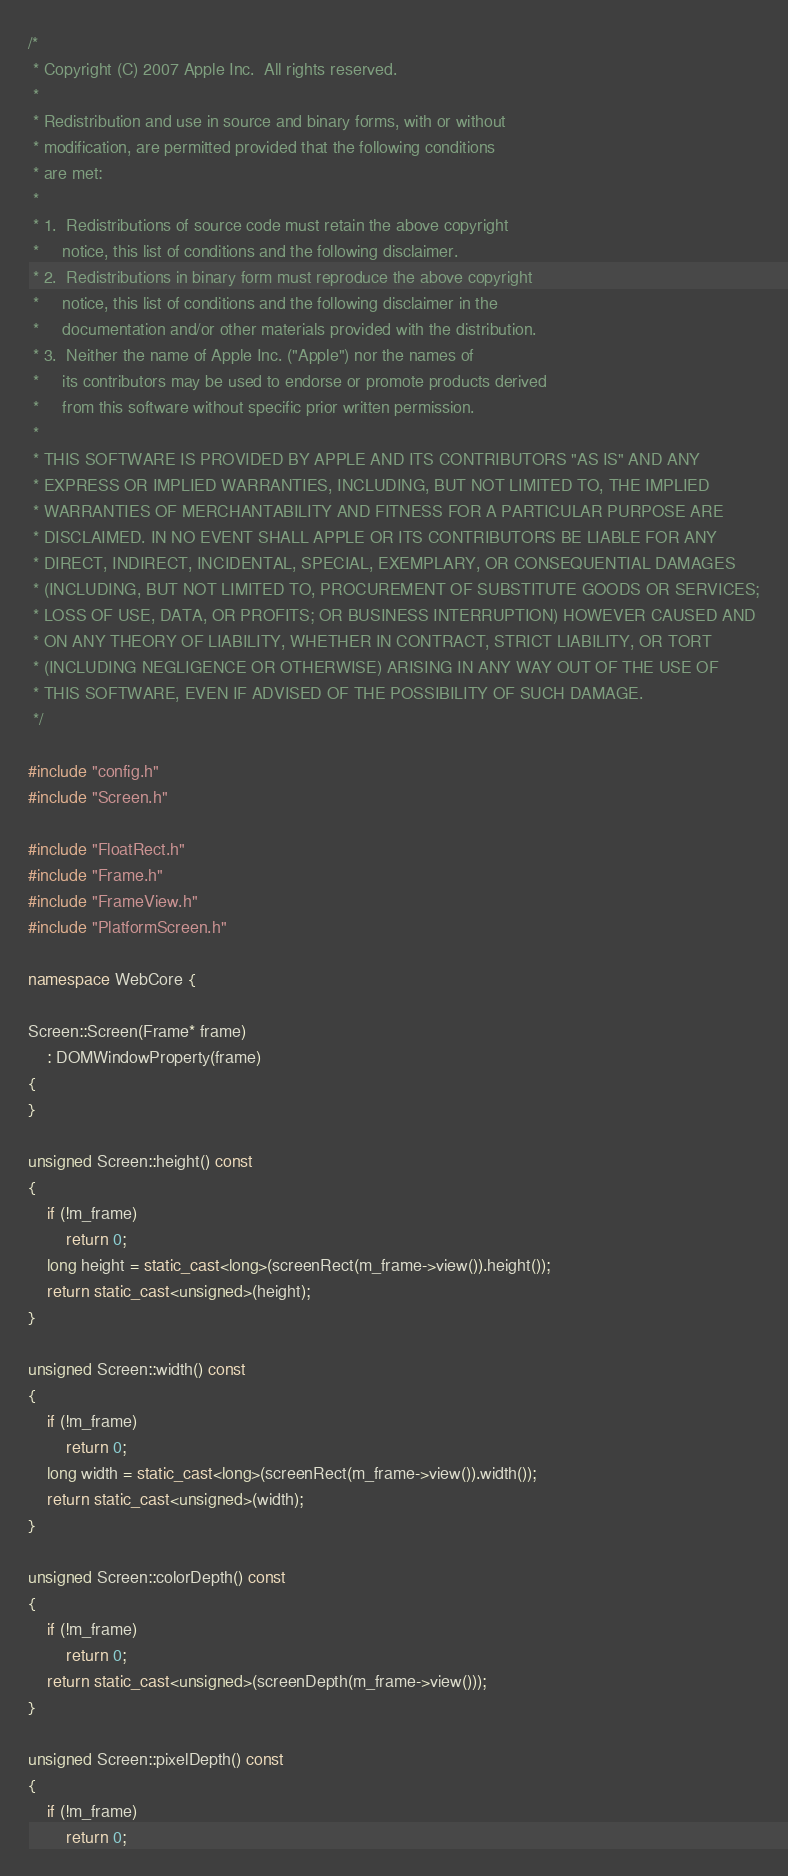Convert code to text. <code><loc_0><loc_0><loc_500><loc_500><_C++_>/*
 * Copyright (C) 2007 Apple Inc.  All rights reserved.
 *
 * Redistribution and use in source and binary forms, with or without
 * modification, are permitted provided that the following conditions
 * are met:
 *
 * 1.  Redistributions of source code must retain the above copyright
 *     notice, this list of conditions and the following disclaimer. 
 * 2.  Redistributions in binary form must reproduce the above copyright
 *     notice, this list of conditions and the following disclaimer in the
 *     documentation and/or other materials provided with the distribution. 
 * 3.  Neither the name of Apple Inc. ("Apple") nor the names of
 *     its contributors may be used to endorse or promote products derived
 *     from this software without specific prior written permission. 
 *
 * THIS SOFTWARE IS PROVIDED BY APPLE AND ITS CONTRIBUTORS "AS IS" AND ANY
 * EXPRESS OR IMPLIED WARRANTIES, INCLUDING, BUT NOT LIMITED TO, THE IMPLIED
 * WARRANTIES OF MERCHANTABILITY AND FITNESS FOR A PARTICULAR PURPOSE ARE
 * DISCLAIMED. IN NO EVENT SHALL APPLE OR ITS CONTRIBUTORS BE LIABLE FOR ANY
 * DIRECT, INDIRECT, INCIDENTAL, SPECIAL, EXEMPLARY, OR CONSEQUENTIAL DAMAGES
 * (INCLUDING, BUT NOT LIMITED TO, PROCUREMENT OF SUBSTITUTE GOODS OR SERVICES;
 * LOSS OF USE, DATA, OR PROFITS; OR BUSINESS INTERRUPTION) HOWEVER CAUSED AND
 * ON ANY THEORY OF LIABILITY, WHETHER IN CONTRACT, STRICT LIABILITY, OR TORT
 * (INCLUDING NEGLIGENCE OR OTHERWISE) ARISING IN ANY WAY OUT OF THE USE OF
 * THIS SOFTWARE, EVEN IF ADVISED OF THE POSSIBILITY OF SUCH DAMAGE.
 */

#include "config.h"
#include "Screen.h"

#include "FloatRect.h"
#include "Frame.h"
#include "FrameView.h"
#include "PlatformScreen.h"

namespace WebCore {

Screen::Screen(Frame* frame)
    : DOMWindowProperty(frame)
{
}

unsigned Screen::height() const
{
    if (!m_frame)
        return 0;
    long height = static_cast<long>(screenRect(m_frame->view()).height());
    return static_cast<unsigned>(height);
}

unsigned Screen::width() const
{
    if (!m_frame)
        return 0;
    long width = static_cast<long>(screenRect(m_frame->view()).width());
    return static_cast<unsigned>(width);
}

unsigned Screen::colorDepth() const
{
    if (!m_frame)
        return 0;
    return static_cast<unsigned>(screenDepth(m_frame->view()));
}

unsigned Screen::pixelDepth() const
{
    if (!m_frame)
        return 0;</code> 